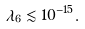Convert formula to latex. <formula><loc_0><loc_0><loc_500><loc_500>\lambda _ { 6 } \lesssim 1 0 ^ { - 1 5 } .</formula> 